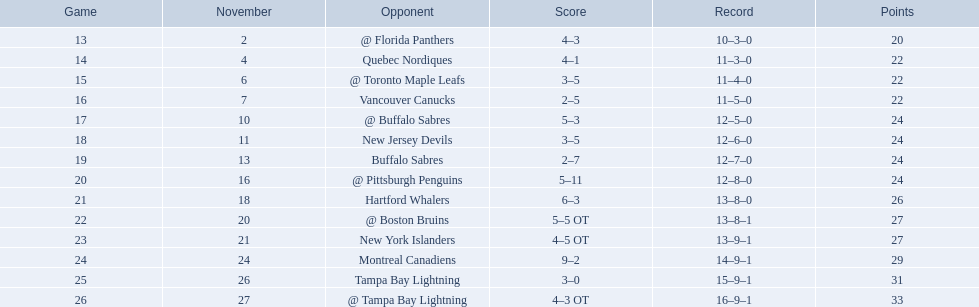What were the scores? @ Florida Panthers, 4–3, Quebec Nordiques, 4–1, @ Toronto Maple Leafs, 3–5, Vancouver Canucks, 2–5, @ Buffalo Sabres, 5–3, New Jersey Devils, 3–5, Buffalo Sabres, 2–7, @ Pittsburgh Penguins, 5–11, Hartford Whalers, 6–3, @ Boston Bruins, 5–5 OT, New York Islanders, 4–5 OT, Montreal Canadiens, 9–2, Tampa Bay Lightning, 3–0, @ Tampa Bay Lightning, 4–3 OT. What score was the closest? New York Islanders, 4–5 OT. What team had that score? New York Islanders. Which teams accumulated 35 or more points? Hartford Whalers, @ Boston Bruins, New York Islanders, Montreal Canadiens, Tampa Bay Lightning, @ Tampa Bay Lightning. Out of these, which team had a unique 3-0 score? Tampa Bay Lightning. 